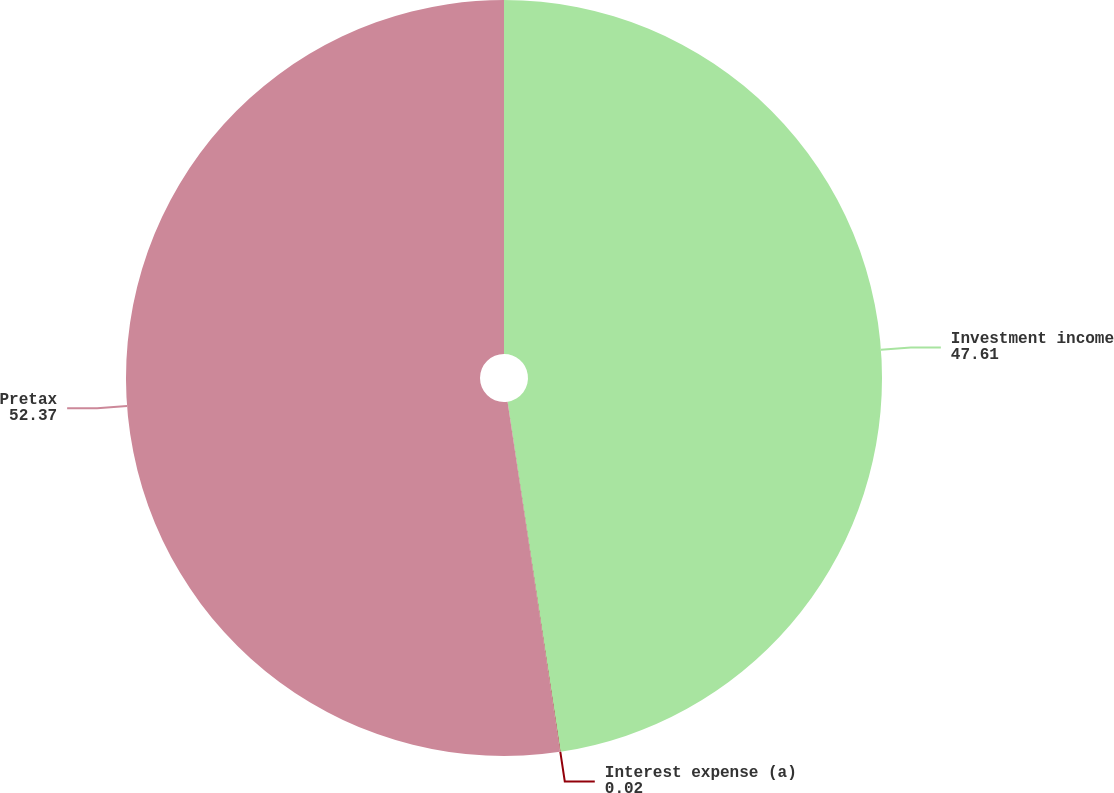Convert chart to OTSL. <chart><loc_0><loc_0><loc_500><loc_500><pie_chart><fcel>Investment income<fcel>Interest expense (a)<fcel>Pretax<nl><fcel>47.61%<fcel>0.02%<fcel>52.37%<nl></chart> 